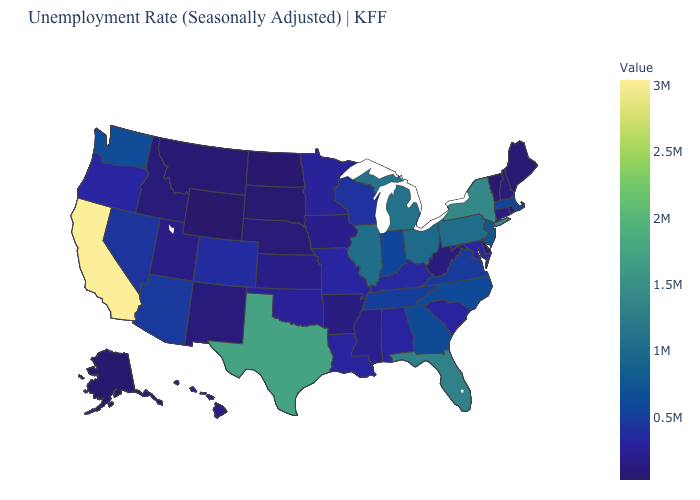Which states have the lowest value in the USA?
Answer briefly. Wyoming. Is the legend a continuous bar?
Short answer required. Yes. Among the states that border Pennsylvania , does Ohio have the lowest value?
Be succinct. No. Is the legend a continuous bar?
Quick response, please. Yes. 